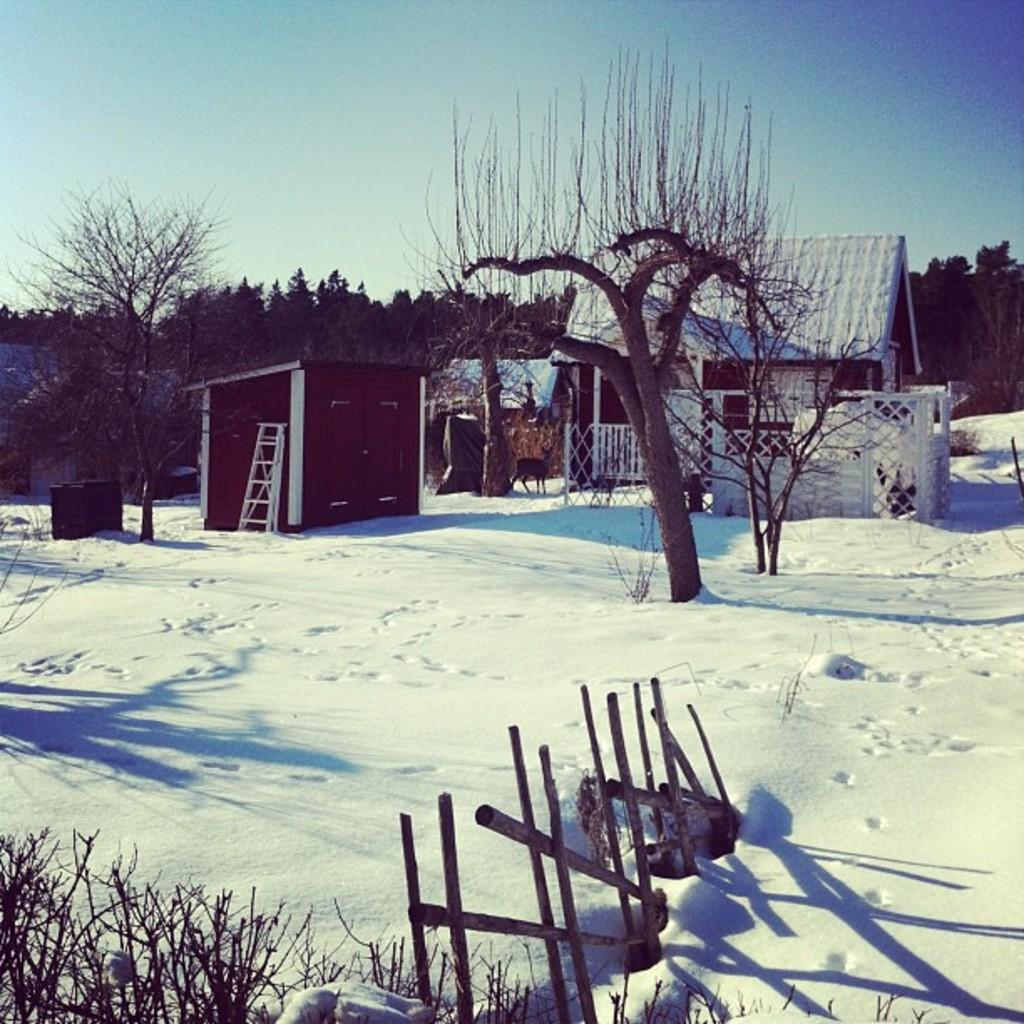What type of weather is depicted in the image? There is snow on the floor in the image, indicating a winter scene. What structures can be seen in the image? There are buildings in the image. What type of natural elements are present in the image? There are trees in the image. What is the condition of the sky in the image? The sky is clear in the image. What type of show is being performed in the image? There is no show or performance depicted in the image; it features snow, buildings, trees, and a clear sky. Can you tell me where the brother is located in the image? There is no mention of a brother or any person in the image; it only shows snow, buildings, trees, and a clear sky. 